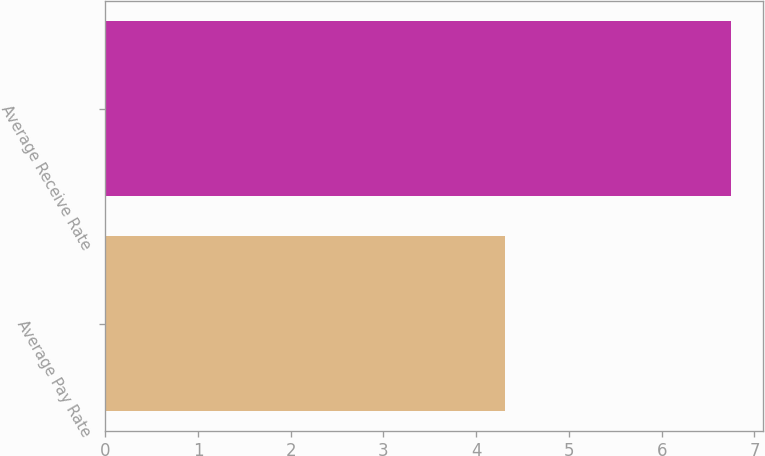<chart> <loc_0><loc_0><loc_500><loc_500><bar_chart><fcel>Average Pay Rate<fcel>Average Receive Rate<nl><fcel>4.31<fcel>6.75<nl></chart> 